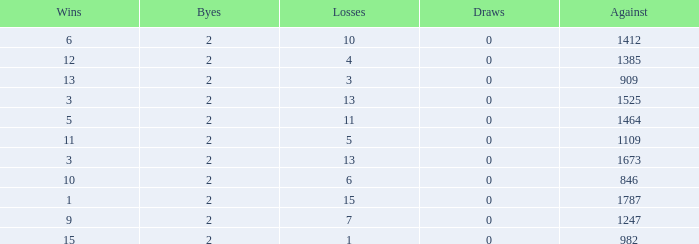What is the highest number listed under against when there were less than 3 wins and less than 15 losses? None. 